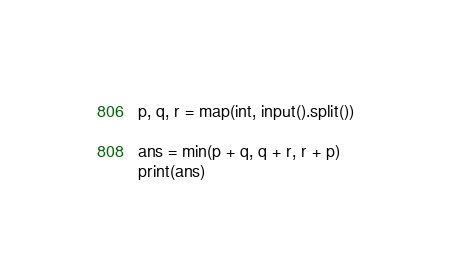Convert code to text. <code><loc_0><loc_0><loc_500><loc_500><_Python_>p, q, r = map(int, input().split())

ans = min(p + q, q + r, r + p)
print(ans)</code> 